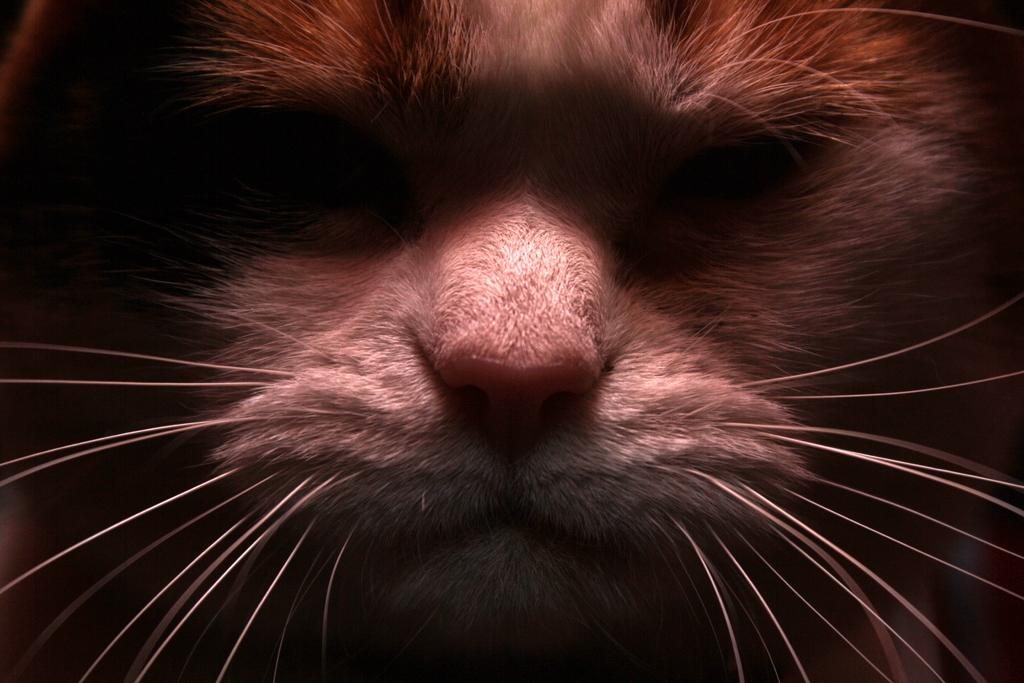What is the main subject of the image? The main subject of the image is a cat's face. What type of tent can be seen in the background of the image? There is no tent present in the image; it only features a cat's face. What message is conveyed by the sign in the image? There is no sign present in the image; it only features a cat's face. 